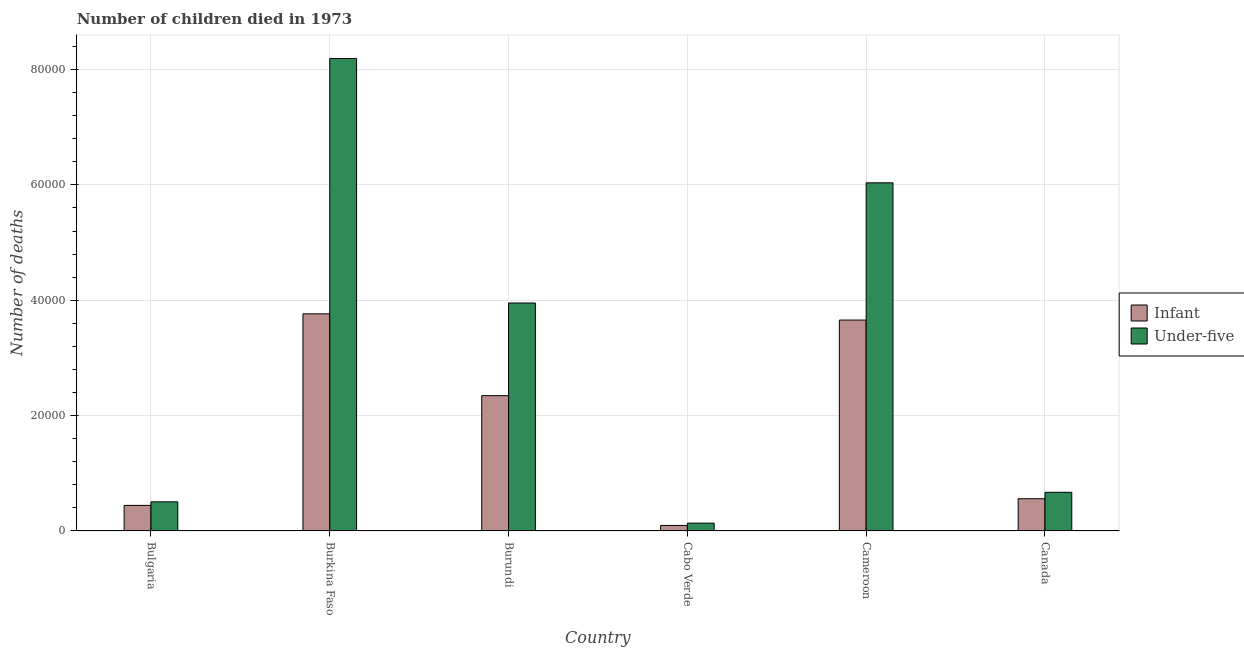How many different coloured bars are there?
Provide a succinct answer. 2. Are the number of bars on each tick of the X-axis equal?
Provide a short and direct response. Yes. How many bars are there on the 6th tick from the left?
Your response must be concise. 2. How many bars are there on the 6th tick from the right?
Ensure brevity in your answer.  2. What is the label of the 2nd group of bars from the left?
Provide a succinct answer. Burkina Faso. In how many cases, is the number of bars for a given country not equal to the number of legend labels?
Keep it short and to the point. 0. What is the number of infant deaths in Canada?
Your response must be concise. 5586. Across all countries, what is the maximum number of infant deaths?
Offer a terse response. 3.76e+04. Across all countries, what is the minimum number of infant deaths?
Give a very brief answer. 952. In which country was the number of under-five deaths maximum?
Ensure brevity in your answer.  Burkina Faso. In which country was the number of under-five deaths minimum?
Offer a very short reply. Cabo Verde. What is the total number of infant deaths in the graph?
Provide a succinct answer. 1.09e+05. What is the difference between the number of infant deaths in Bulgaria and that in Canada?
Your answer should be very brief. -1155. What is the difference between the number of infant deaths in Burkina Faso and the number of under-five deaths in Cameroon?
Provide a short and direct response. -2.27e+04. What is the average number of under-five deaths per country?
Provide a succinct answer. 3.25e+04. What is the difference between the number of infant deaths and number of under-five deaths in Cameroon?
Provide a short and direct response. -2.38e+04. What is the ratio of the number of under-five deaths in Burundi to that in Cabo Verde?
Ensure brevity in your answer.  29.17. What is the difference between the highest and the second highest number of infant deaths?
Provide a succinct answer. 1078. What is the difference between the highest and the lowest number of infant deaths?
Offer a very short reply. 3.67e+04. Is the sum of the number of infant deaths in Bulgaria and Canada greater than the maximum number of under-five deaths across all countries?
Keep it short and to the point. No. What does the 1st bar from the left in Bulgaria represents?
Your answer should be very brief. Infant. What does the 1st bar from the right in Cabo Verde represents?
Offer a very short reply. Under-five. How many bars are there?
Provide a short and direct response. 12. What is the difference between two consecutive major ticks on the Y-axis?
Ensure brevity in your answer.  2.00e+04. Are the values on the major ticks of Y-axis written in scientific E-notation?
Offer a very short reply. No. Does the graph contain any zero values?
Ensure brevity in your answer.  No. Does the graph contain grids?
Offer a terse response. Yes. How many legend labels are there?
Your answer should be very brief. 2. How are the legend labels stacked?
Offer a terse response. Vertical. What is the title of the graph?
Give a very brief answer. Number of children died in 1973. What is the label or title of the X-axis?
Ensure brevity in your answer.  Country. What is the label or title of the Y-axis?
Provide a succinct answer. Number of deaths. What is the Number of deaths in Infant in Bulgaria?
Your answer should be very brief. 4431. What is the Number of deaths in Under-five in Bulgaria?
Ensure brevity in your answer.  5046. What is the Number of deaths in Infant in Burkina Faso?
Offer a terse response. 3.76e+04. What is the Number of deaths in Under-five in Burkina Faso?
Your answer should be compact. 8.19e+04. What is the Number of deaths of Infant in Burundi?
Provide a short and direct response. 2.35e+04. What is the Number of deaths of Under-five in Burundi?
Provide a succinct answer. 3.95e+04. What is the Number of deaths of Infant in Cabo Verde?
Provide a short and direct response. 952. What is the Number of deaths in Under-five in Cabo Verde?
Provide a succinct answer. 1355. What is the Number of deaths in Infant in Cameroon?
Give a very brief answer. 3.66e+04. What is the Number of deaths in Under-five in Cameroon?
Your response must be concise. 6.04e+04. What is the Number of deaths in Infant in Canada?
Provide a short and direct response. 5586. What is the Number of deaths of Under-five in Canada?
Ensure brevity in your answer.  6699. Across all countries, what is the maximum Number of deaths in Infant?
Your answer should be very brief. 3.76e+04. Across all countries, what is the maximum Number of deaths of Under-five?
Give a very brief answer. 8.19e+04. Across all countries, what is the minimum Number of deaths of Infant?
Provide a succinct answer. 952. Across all countries, what is the minimum Number of deaths in Under-five?
Give a very brief answer. 1355. What is the total Number of deaths of Infant in the graph?
Provide a short and direct response. 1.09e+05. What is the total Number of deaths of Under-five in the graph?
Ensure brevity in your answer.  1.95e+05. What is the difference between the Number of deaths in Infant in Bulgaria and that in Burkina Faso?
Keep it short and to the point. -3.32e+04. What is the difference between the Number of deaths of Under-five in Bulgaria and that in Burkina Faso?
Your answer should be very brief. -7.69e+04. What is the difference between the Number of deaths in Infant in Bulgaria and that in Burundi?
Provide a short and direct response. -1.90e+04. What is the difference between the Number of deaths of Under-five in Bulgaria and that in Burundi?
Offer a terse response. -3.45e+04. What is the difference between the Number of deaths of Infant in Bulgaria and that in Cabo Verde?
Keep it short and to the point. 3479. What is the difference between the Number of deaths in Under-five in Bulgaria and that in Cabo Verde?
Offer a very short reply. 3691. What is the difference between the Number of deaths in Infant in Bulgaria and that in Cameroon?
Give a very brief answer. -3.21e+04. What is the difference between the Number of deaths of Under-five in Bulgaria and that in Cameroon?
Offer a terse response. -5.53e+04. What is the difference between the Number of deaths in Infant in Bulgaria and that in Canada?
Your answer should be compact. -1155. What is the difference between the Number of deaths of Under-five in Bulgaria and that in Canada?
Your answer should be compact. -1653. What is the difference between the Number of deaths in Infant in Burkina Faso and that in Burundi?
Your answer should be compact. 1.42e+04. What is the difference between the Number of deaths in Under-five in Burkina Faso and that in Burundi?
Give a very brief answer. 4.24e+04. What is the difference between the Number of deaths in Infant in Burkina Faso and that in Cabo Verde?
Provide a succinct answer. 3.67e+04. What is the difference between the Number of deaths in Under-five in Burkina Faso and that in Cabo Verde?
Give a very brief answer. 8.06e+04. What is the difference between the Number of deaths in Infant in Burkina Faso and that in Cameroon?
Ensure brevity in your answer.  1078. What is the difference between the Number of deaths in Under-five in Burkina Faso and that in Cameroon?
Provide a short and direct response. 2.16e+04. What is the difference between the Number of deaths in Infant in Burkina Faso and that in Canada?
Your answer should be very brief. 3.21e+04. What is the difference between the Number of deaths of Under-five in Burkina Faso and that in Canada?
Offer a terse response. 7.52e+04. What is the difference between the Number of deaths in Infant in Burundi and that in Cabo Verde?
Your response must be concise. 2.25e+04. What is the difference between the Number of deaths of Under-five in Burundi and that in Cabo Verde?
Provide a succinct answer. 3.82e+04. What is the difference between the Number of deaths in Infant in Burundi and that in Cameroon?
Offer a terse response. -1.31e+04. What is the difference between the Number of deaths in Under-five in Burundi and that in Cameroon?
Ensure brevity in your answer.  -2.08e+04. What is the difference between the Number of deaths of Infant in Burundi and that in Canada?
Offer a very short reply. 1.79e+04. What is the difference between the Number of deaths in Under-five in Burundi and that in Canada?
Give a very brief answer. 3.28e+04. What is the difference between the Number of deaths of Infant in Cabo Verde and that in Cameroon?
Your answer should be very brief. -3.56e+04. What is the difference between the Number of deaths in Under-five in Cabo Verde and that in Cameroon?
Your answer should be compact. -5.90e+04. What is the difference between the Number of deaths in Infant in Cabo Verde and that in Canada?
Offer a terse response. -4634. What is the difference between the Number of deaths of Under-five in Cabo Verde and that in Canada?
Make the answer very short. -5344. What is the difference between the Number of deaths in Infant in Cameroon and that in Canada?
Your response must be concise. 3.10e+04. What is the difference between the Number of deaths in Under-five in Cameroon and that in Canada?
Provide a succinct answer. 5.37e+04. What is the difference between the Number of deaths of Infant in Bulgaria and the Number of deaths of Under-five in Burkina Faso?
Your answer should be compact. -7.75e+04. What is the difference between the Number of deaths of Infant in Bulgaria and the Number of deaths of Under-five in Burundi?
Offer a terse response. -3.51e+04. What is the difference between the Number of deaths of Infant in Bulgaria and the Number of deaths of Under-five in Cabo Verde?
Give a very brief answer. 3076. What is the difference between the Number of deaths in Infant in Bulgaria and the Number of deaths in Under-five in Cameroon?
Keep it short and to the point. -5.59e+04. What is the difference between the Number of deaths in Infant in Bulgaria and the Number of deaths in Under-five in Canada?
Your answer should be very brief. -2268. What is the difference between the Number of deaths in Infant in Burkina Faso and the Number of deaths in Under-five in Burundi?
Your answer should be compact. -1880. What is the difference between the Number of deaths of Infant in Burkina Faso and the Number of deaths of Under-five in Cabo Verde?
Keep it short and to the point. 3.63e+04. What is the difference between the Number of deaths in Infant in Burkina Faso and the Number of deaths in Under-five in Cameroon?
Your response must be concise. -2.27e+04. What is the difference between the Number of deaths in Infant in Burkina Faso and the Number of deaths in Under-five in Canada?
Keep it short and to the point. 3.09e+04. What is the difference between the Number of deaths in Infant in Burundi and the Number of deaths in Under-five in Cabo Verde?
Offer a very short reply. 2.21e+04. What is the difference between the Number of deaths of Infant in Burundi and the Number of deaths of Under-five in Cameroon?
Give a very brief answer. -3.69e+04. What is the difference between the Number of deaths in Infant in Burundi and the Number of deaths in Under-five in Canada?
Make the answer very short. 1.68e+04. What is the difference between the Number of deaths in Infant in Cabo Verde and the Number of deaths in Under-five in Cameroon?
Your response must be concise. -5.94e+04. What is the difference between the Number of deaths in Infant in Cabo Verde and the Number of deaths in Under-five in Canada?
Give a very brief answer. -5747. What is the difference between the Number of deaths in Infant in Cameroon and the Number of deaths in Under-five in Canada?
Provide a succinct answer. 2.99e+04. What is the average Number of deaths of Infant per country?
Offer a terse response. 1.81e+04. What is the average Number of deaths in Under-five per country?
Your response must be concise. 3.25e+04. What is the difference between the Number of deaths in Infant and Number of deaths in Under-five in Bulgaria?
Your answer should be compact. -615. What is the difference between the Number of deaths in Infant and Number of deaths in Under-five in Burkina Faso?
Provide a succinct answer. -4.43e+04. What is the difference between the Number of deaths in Infant and Number of deaths in Under-five in Burundi?
Your response must be concise. -1.61e+04. What is the difference between the Number of deaths of Infant and Number of deaths of Under-five in Cabo Verde?
Offer a terse response. -403. What is the difference between the Number of deaths in Infant and Number of deaths in Under-five in Cameroon?
Offer a terse response. -2.38e+04. What is the difference between the Number of deaths of Infant and Number of deaths of Under-five in Canada?
Give a very brief answer. -1113. What is the ratio of the Number of deaths of Infant in Bulgaria to that in Burkina Faso?
Make the answer very short. 0.12. What is the ratio of the Number of deaths in Under-five in Bulgaria to that in Burkina Faso?
Offer a terse response. 0.06. What is the ratio of the Number of deaths of Infant in Bulgaria to that in Burundi?
Give a very brief answer. 0.19. What is the ratio of the Number of deaths of Under-five in Bulgaria to that in Burundi?
Your response must be concise. 0.13. What is the ratio of the Number of deaths in Infant in Bulgaria to that in Cabo Verde?
Provide a short and direct response. 4.65. What is the ratio of the Number of deaths in Under-five in Bulgaria to that in Cabo Verde?
Provide a short and direct response. 3.72. What is the ratio of the Number of deaths of Infant in Bulgaria to that in Cameroon?
Give a very brief answer. 0.12. What is the ratio of the Number of deaths in Under-five in Bulgaria to that in Cameroon?
Your response must be concise. 0.08. What is the ratio of the Number of deaths of Infant in Bulgaria to that in Canada?
Your answer should be very brief. 0.79. What is the ratio of the Number of deaths in Under-five in Bulgaria to that in Canada?
Make the answer very short. 0.75. What is the ratio of the Number of deaths of Infant in Burkina Faso to that in Burundi?
Keep it short and to the point. 1.6. What is the ratio of the Number of deaths of Under-five in Burkina Faso to that in Burundi?
Your answer should be very brief. 2.07. What is the ratio of the Number of deaths of Infant in Burkina Faso to that in Cabo Verde?
Offer a terse response. 39.54. What is the ratio of the Number of deaths in Under-five in Burkina Faso to that in Cabo Verde?
Offer a terse response. 60.45. What is the ratio of the Number of deaths in Infant in Burkina Faso to that in Cameroon?
Ensure brevity in your answer.  1.03. What is the ratio of the Number of deaths in Under-five in Burkina Faso to that in Cameroon?
Keep it short and to the point. 1.36. What is the ratio of the Number of deaths in Infant in Burkina Faso to that in Canada?
Provide a short and direct response. 6.74. What is the ratio of the Number of deaths of Under-five in Burkina Faso to that in Canada?
Offer a terse response. 12.23. What is the ratio of the Number of deaths in Infant in Burundi to that in Cabo Verde?
Offer a terse response. 24.64. What is the ratio of the Number of deaths of Under-five in Burundi to that in Cabo Verde?
Your answer should be compact. 29.17. What is the ratio of the Number of deaths in Infant in Burundi to that in Cameroon?
Offer a terse response. 0.64. What is the ratio of the Number of deaths of Under-five in Burundi to that in Cameroon?
Offer a very short reply. 0.65. What is the ratio of the Number of deaths in Infant in Burundi to that in Canada?
Offer a terse response. 4.2. What is the ratio of the Number of deaths in Under-five in Burundi to that in Canada?
Provide a short and direct response. 5.9. What is the ratio of the Number of deaths of Infant in Cabo Verde to that in Cameroon?
Keep it short and to the point. 0.03. What is the ratio of the Number of deaths of Under-five in Cabo Verde to that in Cameroon?
Provide a succinct answer. 0.02. What is the ratio of the Number of deaths of Infant in Cabo Verde to that in Canada?
Provide a short and direct response. 0.17. What is the ratio of the Number of deaths in Under-five in Cabo Verde to that in Canada?
Your response must be concise. 0.2. What is the ratio of the Number of deaths in Infant in Cameroon to that in Canada?
Your response must be concise. 6.55. What is the ratio of the Number of deaths in Under-five in Cameroon to that in Canada?
Your response must be concise. 9.01. What is the difference between the highest and the second highest Number of deaths of Infant?
Give a very brief answer. 1078. What is the difference between the highest and the second highest Number of deaths in Under-five?
Offer a terse response. 2.16e+04. What is the difference between the highest and the lowest Number of deaths of Infant?
Your answer should be compact. 3.67e+04. What is the difference between the highest and the lowest Number of deaths in Under-five?
Ensure brevity in your answer.  8.06e+04. 